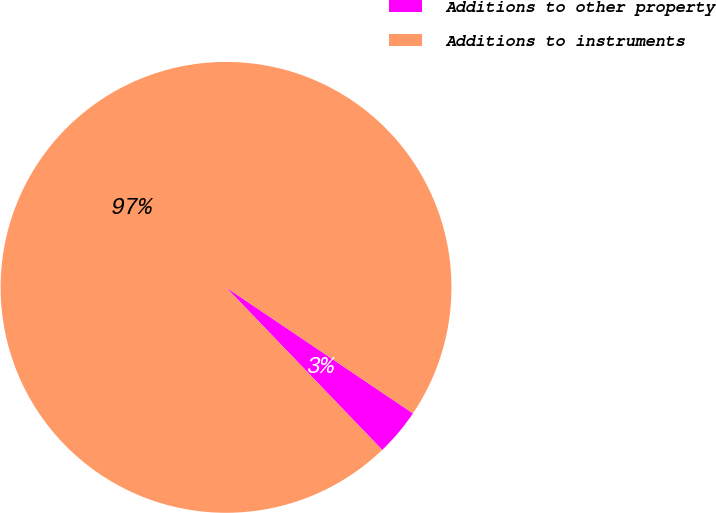<chart> <loc_0><loc_0><loc_500><loc_500><pie_chart><fcel>Additions to other property<fcel>Additions to instruments<nl><fcel>3.38%<fcel>96.62%<nl></chart> 